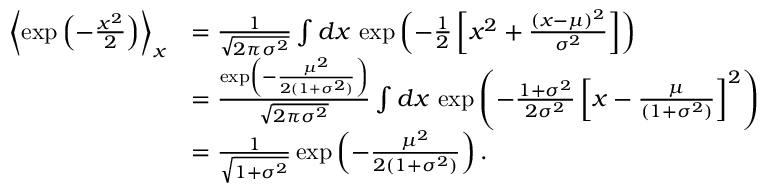<formula> <loc_0><loc_0><loc_500><loc_500>\begin{array} { r l } { \left \langle \exp \left ( - \frac { x ^ { 2 } } { 2 } \right ) \right \rangle _ { x } } & { = \frac { 1 } { \sqrt { 2 \pi \sigma ^ { 2 } } } \int d x \, \exp \left ( - \frac { 1 } { 2 } \left [ x ^ { 2 } + \frac { ( x - \mu ) ^ { 2 } } { \sigma ^ { 2 } } \right ] \right ) } \\ & { = \frac { \exp \left ( - \frac { \mu ^ { 2 } } { 2 ( 1 + \sigma ^ { 2 } ) } \right ) } { \sqrt { 2 \pi \sigma ^ { 2 } } } \int d x \, \exp \left ( - \frac { 1 + \sigma ^ { 2 } } { 2 \sigma ^ { 2 } } \left [ x - \frac { \mu } { ( 1 + \sigma ^ { 2 } ) } \right ] ^ { 2 } \right ) } \\ & { = \frac { 1 } { \sqrt { 1 + \sigma ^ { 2 } } } \exp \left ( - \frac { \mu ^ { 2 } } { 2 ( 1 + \sigma ^ { 2 } ) } \right ) . } \end{array}</formula> 